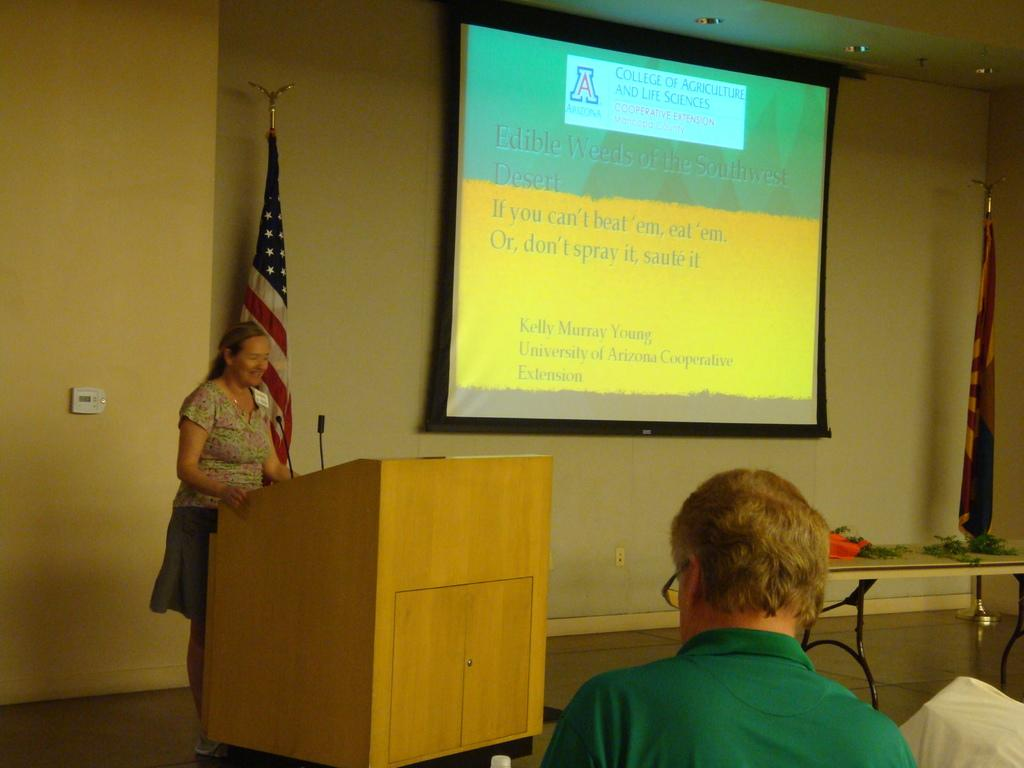What is the woman doing in the image? The woman is standing in front of a podium. What else can be seen in the image? There is a mice, a screen, a table, and a cream-colored wall in the image. Can you describe the person in front of the woman? There is a person in front of the woman, but no specific details about the person are provided. What might the screen be used for in the image? The screen could be used for displaying information or visuals during a presentation or event. What type of dinosaurs can be seen in the image? There are no dinosaurs present in the image. How does the earthquake affect the woman standing in front of the podium? There is no mention of an earthquake in the image, so its effects cannot be determined. 